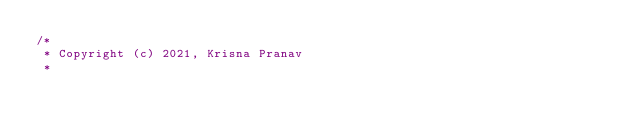<code> <loc_0><loc_0><loc_500><loc_500><_C_>/*
 * Copyright (c) 2021, Krisna Pranav
 *</code> 